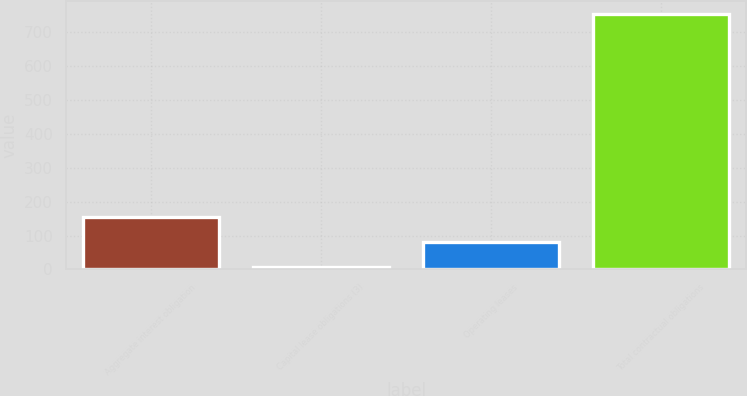Convert chart. <chart><loc_0><loc_0><loc_500><loc_500><bar_chart><fcel>Aggregate interest obligation<fcel>Capital lease obligations (3)<fcel>Operating leases<fcel>Total contractual obligations<nl><fcel>155.8<fcel>6<fcel>80.9<fcel>755<nl></chart> 